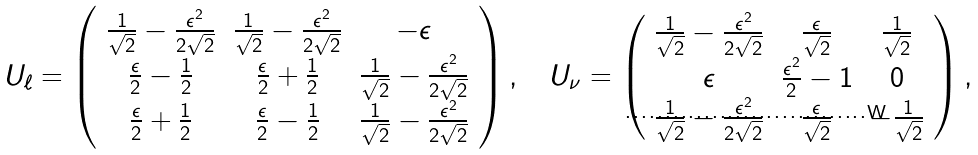Convert formula to latex. <formula><loc_0><loc_0><loc_500><loc_500>U _ { \ell } = \left ( \begin{array} { c c c } \frac { 1 } { \sqrt { 2 } } - \frac { \epsilon ^ { 2 } } { 2 \sqrt { 2 } } & \frac { 1 } { \sqrt { 2 } } - \frac { \epsilon ^ { 2 } } { 2 \sqrt { 2 } } & - \epsilon \\ \frac { \epsilon } { 2 } - \frac { 1 } { 2 } & \frac { \epsilon } { 2 } + \frac { 1 } { 2 } & \frac { 1 } { \sqrt { 2 } } - \frac { \epsilon ^ { 2 } } { 2 \sqrt { 2 } } \\ \frac { \epsilon } { 2 } + \frac { 1 } { 2 } & \frac { \epsilon } { 2 } - \frac { 1 } { 2 } & \frac { 1 } { \sqrt { 2 } } - \frac { \epsilon ^ { 2 } } { 2 \sqrt { 2 } } \end{array} \right ) , \quad U _ { \nu } = \left ( \begin{array} { c c c } \frac { 1 } { \sqrt { 2 } } - \frac { \epsilon ^ { 2 } } { 2 \sqrt { 2 } } & \frac { \epsilon } { \sqrt { 2 } } & \frac { 1 } { \sqrt { 2 } } \\ \epsilon & \frac { \epsilon ^ { 2 } } { 2 } - 1 & 0 \\ \frac { 1 } { \sqrt { 2 } } - \frac { \epsilon ^ { 2 } } { 2 \sqrt { 2 } } & \frac { \epsilon } { \sqrt { 2 } } & - \frac { 1 } { \sqrt { 2 } } \end{array} \right ) ,</formula> 